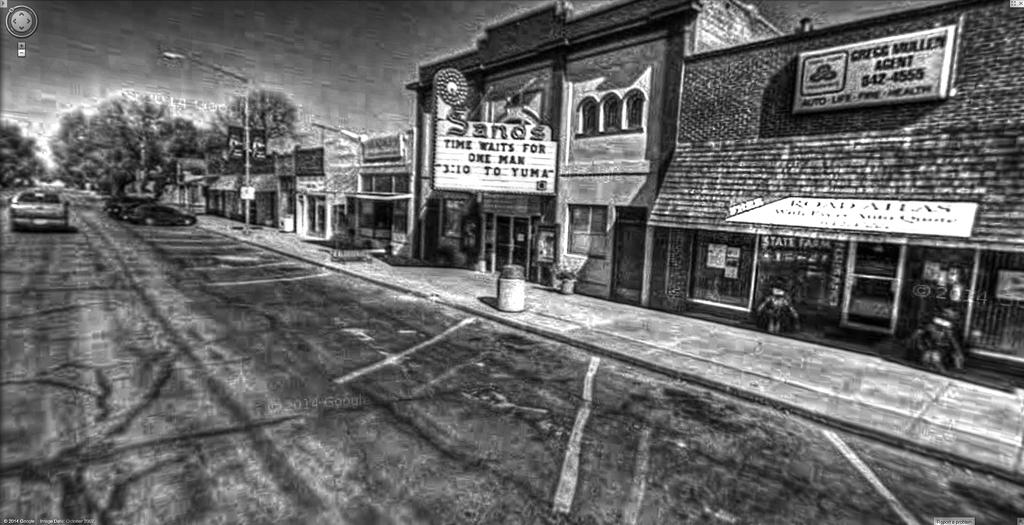<image>
Create a compact narrative representing the image presented. Old photo of a store front for Sands and State Farm. 